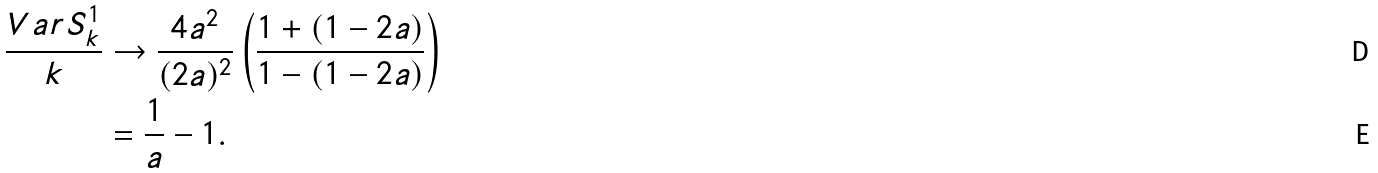Convert formula to latex. <formula><loc_0><loc_0><loc_500><loc_500>\frac { V a r S _ { k } ^ { 1 } } { k } & \rightarrow \frac { 4 a ^ { 2 } } { ( 2 a ) ^ { 2 } } \left ( \frac { 1 + ( 1 - 2 a ) } { 1 - ( 1 - 2 a ) } \right ) \\ & = \frac { 1 } { a } - 1 .</formula> 